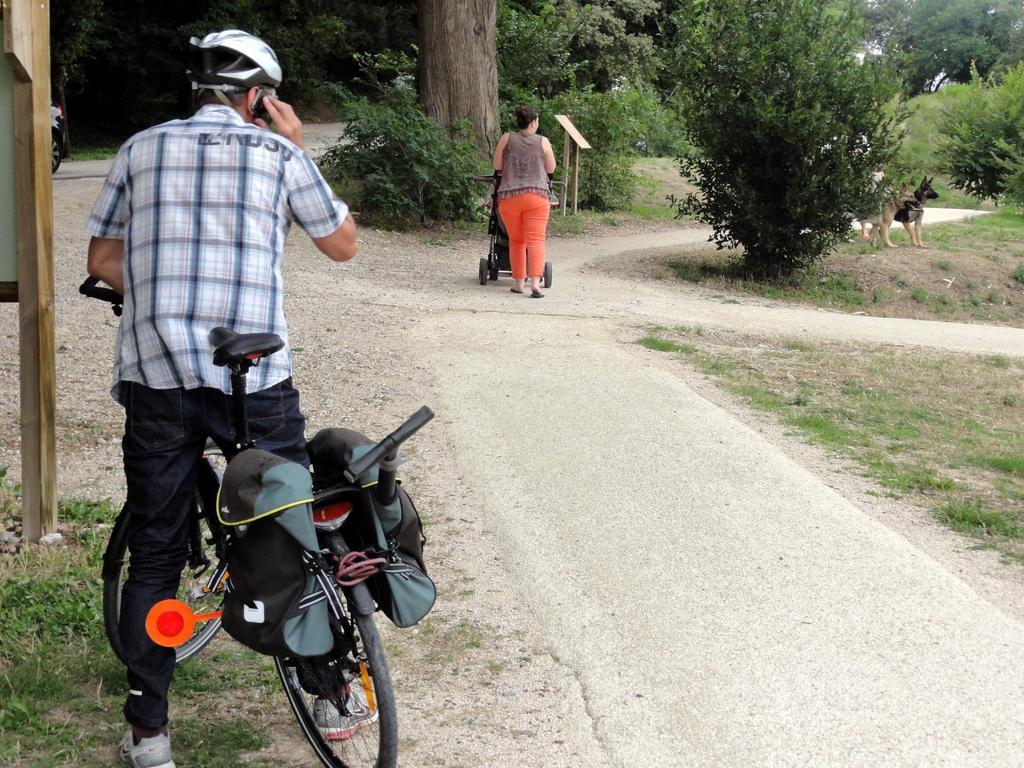Can you describe this image briefly? On the left side of the image we a person is standing on a bicycle and holding a mobile. In the middle of the image we can see a lady is walking and holding something in her hands. On the right side of the image we can see trees and dogs. 